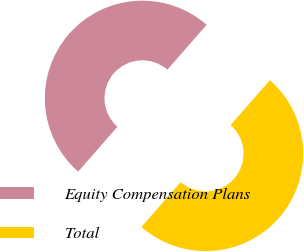<chart> <loc_0><loc_0><loc_500><loc_500><pie_chart><fcel>Equity Compensation Plans<fcel>Total<nl><fcel>50.0%<fcel>50.0%<nl></chart> 